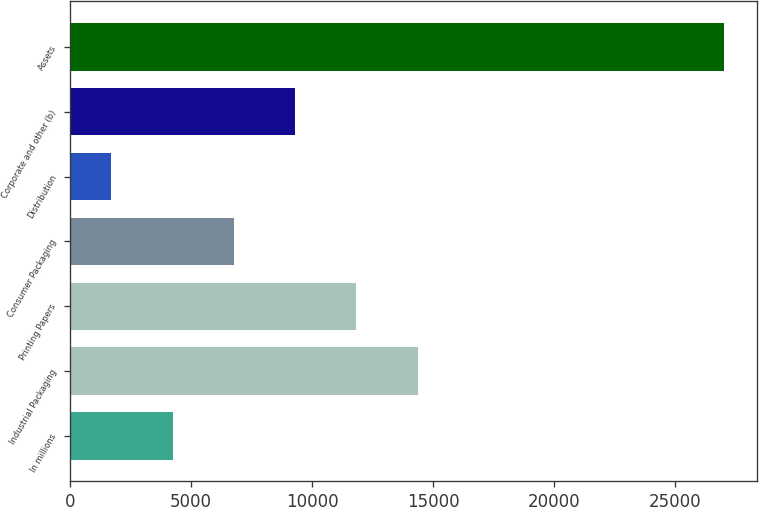<chart> <loc_0><loc_0><loc_500><loc_500><bar_chart><fcel>In millions<fcel>Industrial Packaging<fcel>Printing Papers<fcel>Consumer Packaging<fcel>Distribution<fcel>Corporate and other (b)<fcel>Assets<nl><fcel>4248<fcel>14368<fcel>11838<fcel>6778<fcel>1718<fcel>9308<fcel>27018<nl></chart> 